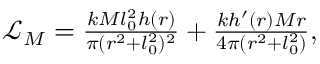Convert formula to latex. <formula><loc_0><loc_0><loc_500><loc_500>\begin{array} { r } { \mathcal { L } _ { M } = \frac { k M l _ { 0 } ^ { 2 } h ( r ) } { \pi ( r ^ { 2 } + l _ { 0 } ^ { 2 } ) ^ { 2 } } + \frac { k h ^ { \prime } ( r ) M r } { 4 \pi ( r ^ { 2 } + l _ { 0 } ^ { 2 } ) } , } \end{array}</formula> 